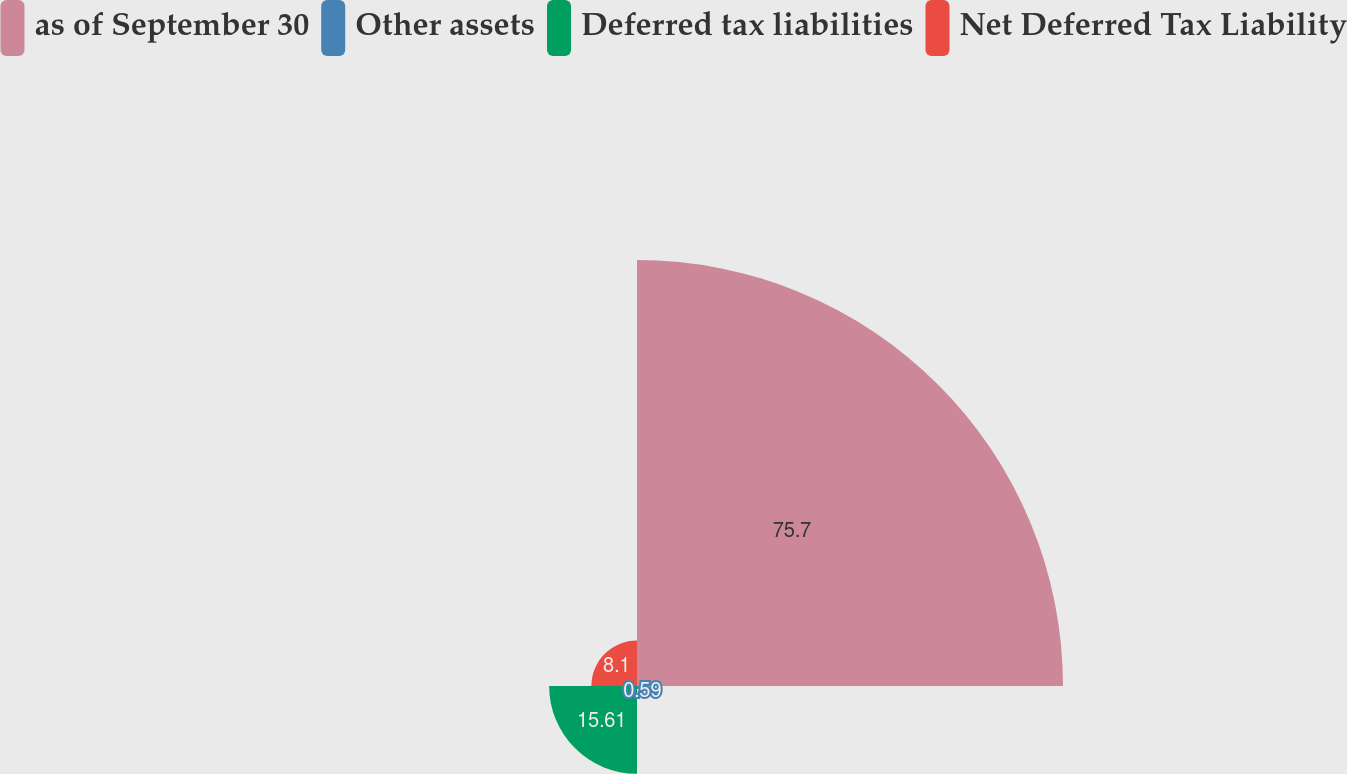Convert chart to OTSL. <chart><loc_0><loc_0><loc_500><loc_500><pie_chart><fcel>as of September 30<fcel>Other assets<fcel>Deferred tax liabilities<fcel>Net Deferred Tax Liability<nl><fcel>75.69%<fcel>0.59%<fcel>15.61%<fcel>8.1%<nl></chart> 